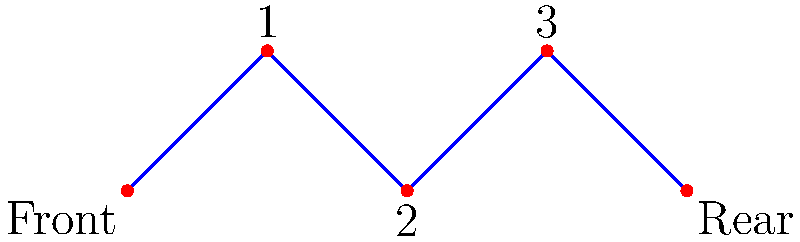In a bicycle's gear system, the front chainring is connected to three rear sprockets via a chain. This system can be represented as a graph, where vertices are the chainring and sprockets, and edges represent the chain connections. Given the graph above, what is the minimum number of edges that need to be removed to disconnect the front chainring from the rear sprocket? To solve this problem, we need to understand the concept of edge connectivity in graph theory. The edge connectivity of a graph is the minimum number of edges that need to be removed to disconnect the graph.

Step 1: Analyze the graph structure
- The graph represents a linear path from the front chainring to the rear sprocket.
- There are 5 vertices in total: the front chainring, 3 intermediate sprockets, and the rear sprocket.
- The vertices are connected by 4 edges in a linear fashion.

Step 2: Identify the critical edges
- In this linear graph, removing any single edge will disconnect the front chainring from the rear sprocket.
- This is because there is only one path from the front to the rear, and each edge is part of this single path.

Step 3: Determine the minimum number of edges to remove
- Since removing any single edge disconnects the graph, the minimum number of edges to remove is 1.

Step 4: Relate to bicycle mechanics
- In a real bicycle, this corresponds to the chain breaking at any point, which would indeed disconnect the front chainring from the rear sprocket.

Therefore, the edge connectivity of this graph is 1, which means removing a minimum of 1 edge will disconnect the front chainring from the rear sprocket.
Answer: 1 